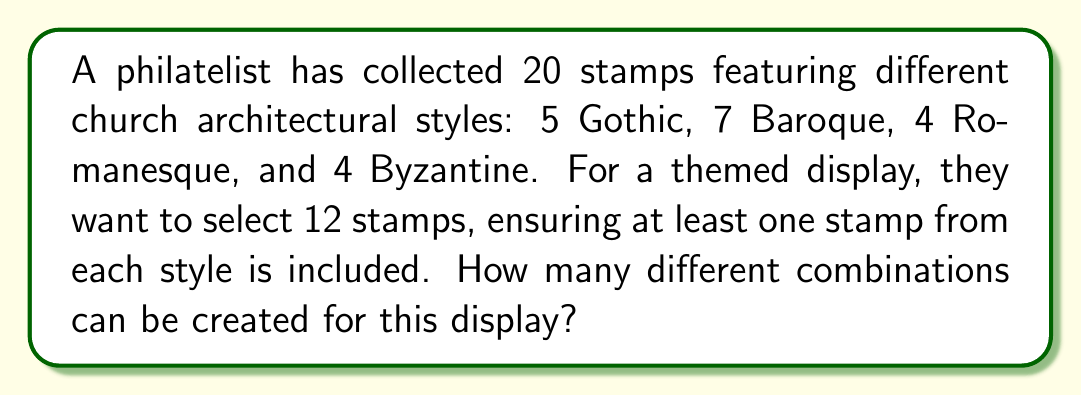Help me with this question. Let's approach this problem step-by-step using the concept of combinations and the inclusion-exclusion principle:

1) First, we need to ensure at least one stamp from each style is included. So, we start by selecting one stamp from each style:
   1 Gothic + 1 Baroque + 1 Romanesque + 1 Byzantine = 4 stamps

2) We now need to select 8 more stamps from the remaining 16 stamps:
   4 Gothic + 6 Baroque + 3 Romanesque + 3 Byzantine = 16 stamps

3) This is a combination problem. We can represent it as $C(16,8)$ or $\binom{16}{8}$.

4) The formula for this combination is:

   $$\binom{16}{8} = \frac{16!}{8!(16-8)!} = \frac{16!}{8!8!}$$

5) Calculating this:
   $$\frac{16 \times 15 \times 14 \times 13 \times 12 \times 11 \times 10 \times 9}{8 \times 7 \times 6 \times 5 \times 4 \times 3 \times 2 \times 1} = 12,870$$

Therefore, there are 12,870 different ways to select the remaining 8 stamps.

However, this calculation assumes that we've already selected one specific stamp from each style. In reality, we have multiple choices for each initial selection:

- 5 choices for Gothic
- 7 choices for Baroque
- 4 choices for Romanesque
- 4 choices for Byzantine

6) To account for these choices, we multiply our previous result by $5 \times 7 \times 4 \times 4$:

   $$12,870 \times 5 \times 7 \times 4 \times 4 = 7,207,200$$

Thus, the total number of possible combinations is 7,207,200.
Answer: 7,207,200 combinations 